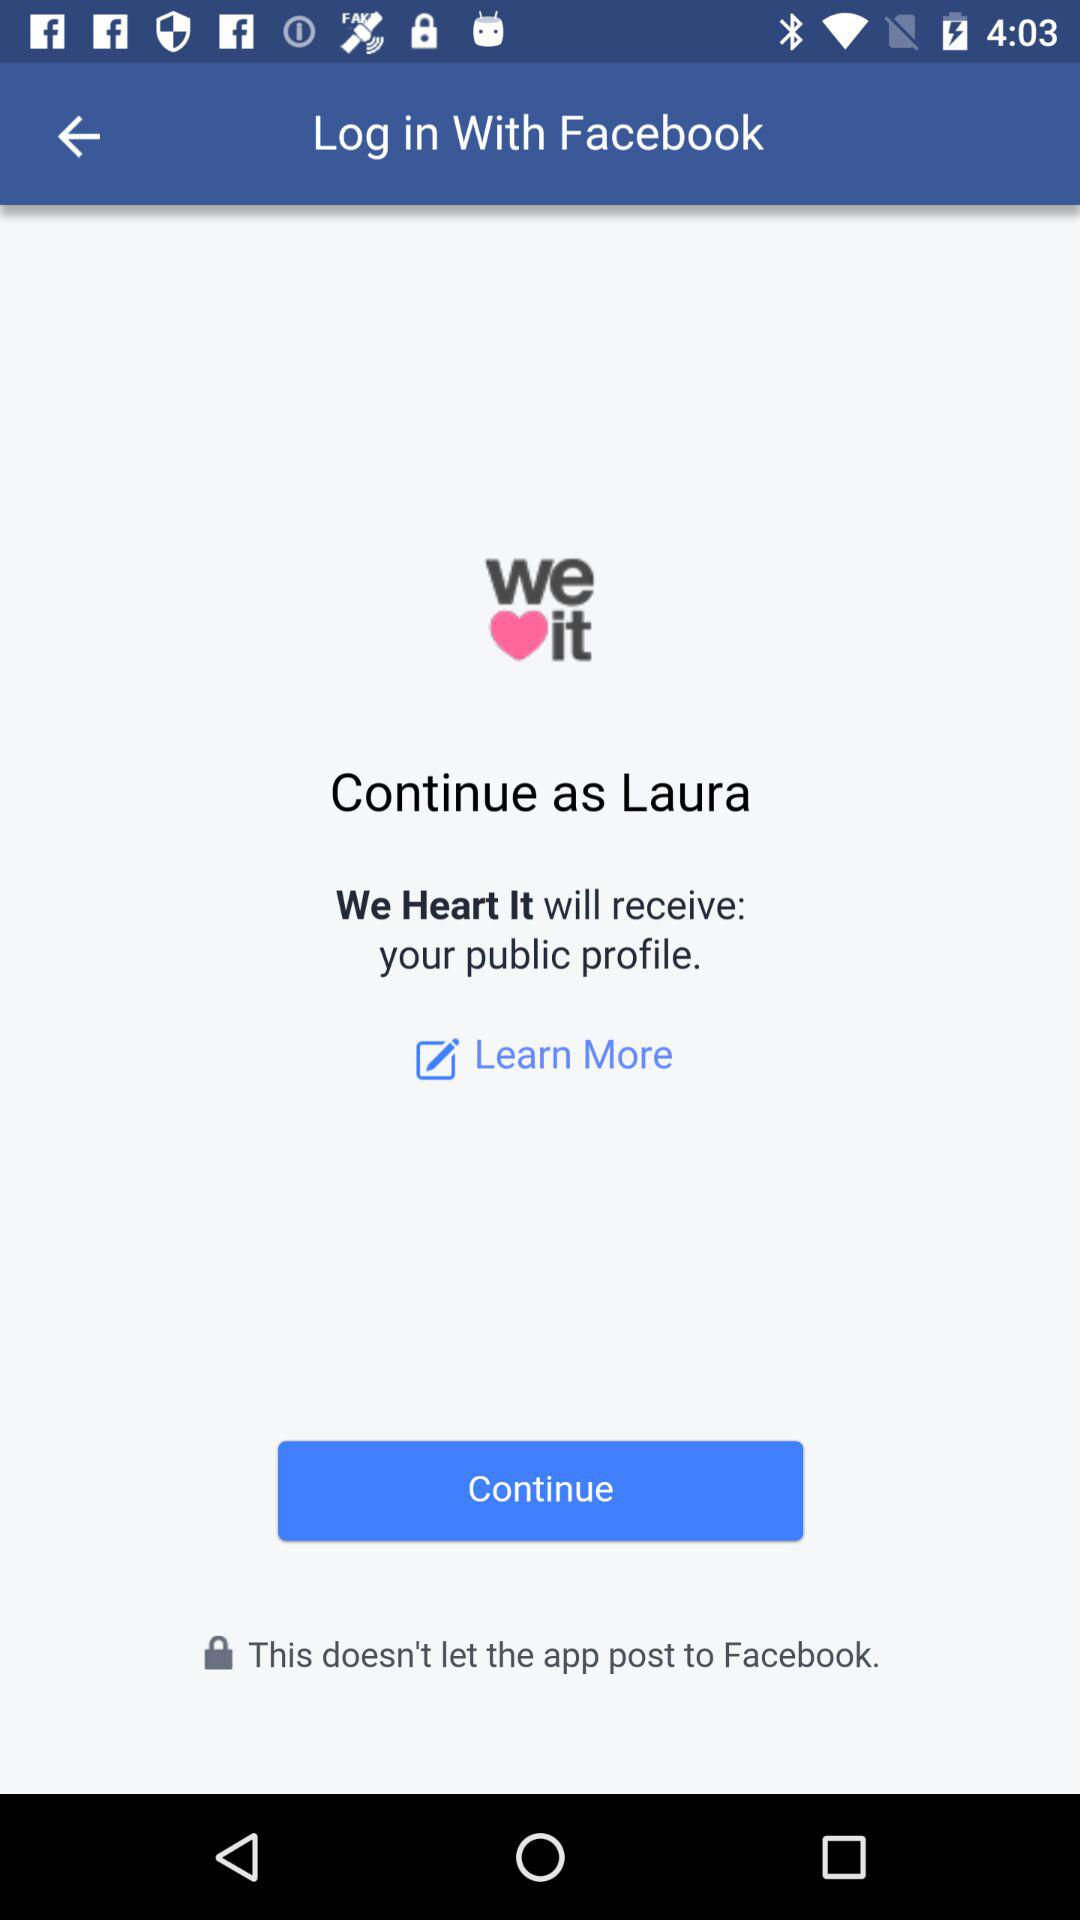What application will receive the public profile? The application that will receive the public profile is "We Heart It". 